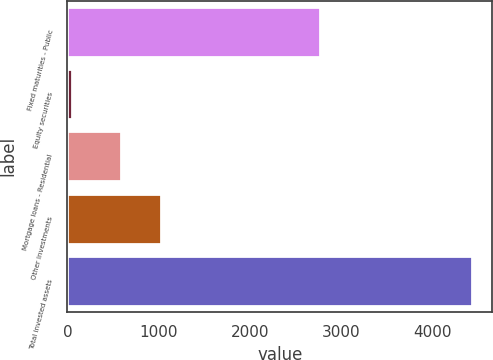Convert chart to OTSL. <chart><loc_0><loc_0><loc_500><loc_500><bar_chart><fcel>Fixed maturities - Public<fcel>Equity securities<fcel>Mortgage loans - Residential<fcel>Other investments<fcel>Total invested assets<nl><fcel>2767.1<fcel>46.7<fcel>587.6<fcel>1025.69<fcel>4427.6<nl></chart> 